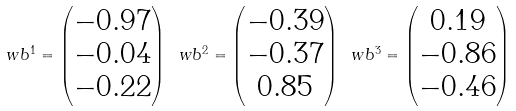Convert formula to latex. <formula><loc_0><loc_0><loc_500><loc_500>\ w b ^ { 1 } = \begin{pmatrix} - 0 . 9 7 \\ - 0 . 0 4 \\ - 0 . 2 2 \end{pmatrix} \ w b ^ { 2 } = \begin{pmatrix} - 0 . 3 9 \\ - 0 . 3 7 \\ 0 . 8 5 \end{pmatrix} \ w b ^ { 3 } = \begin{pmatrix} 0 . 1 9 \\ - 0 . 8 6 \\ - 0 . 4 6 \end{pmatrix}</formula> 